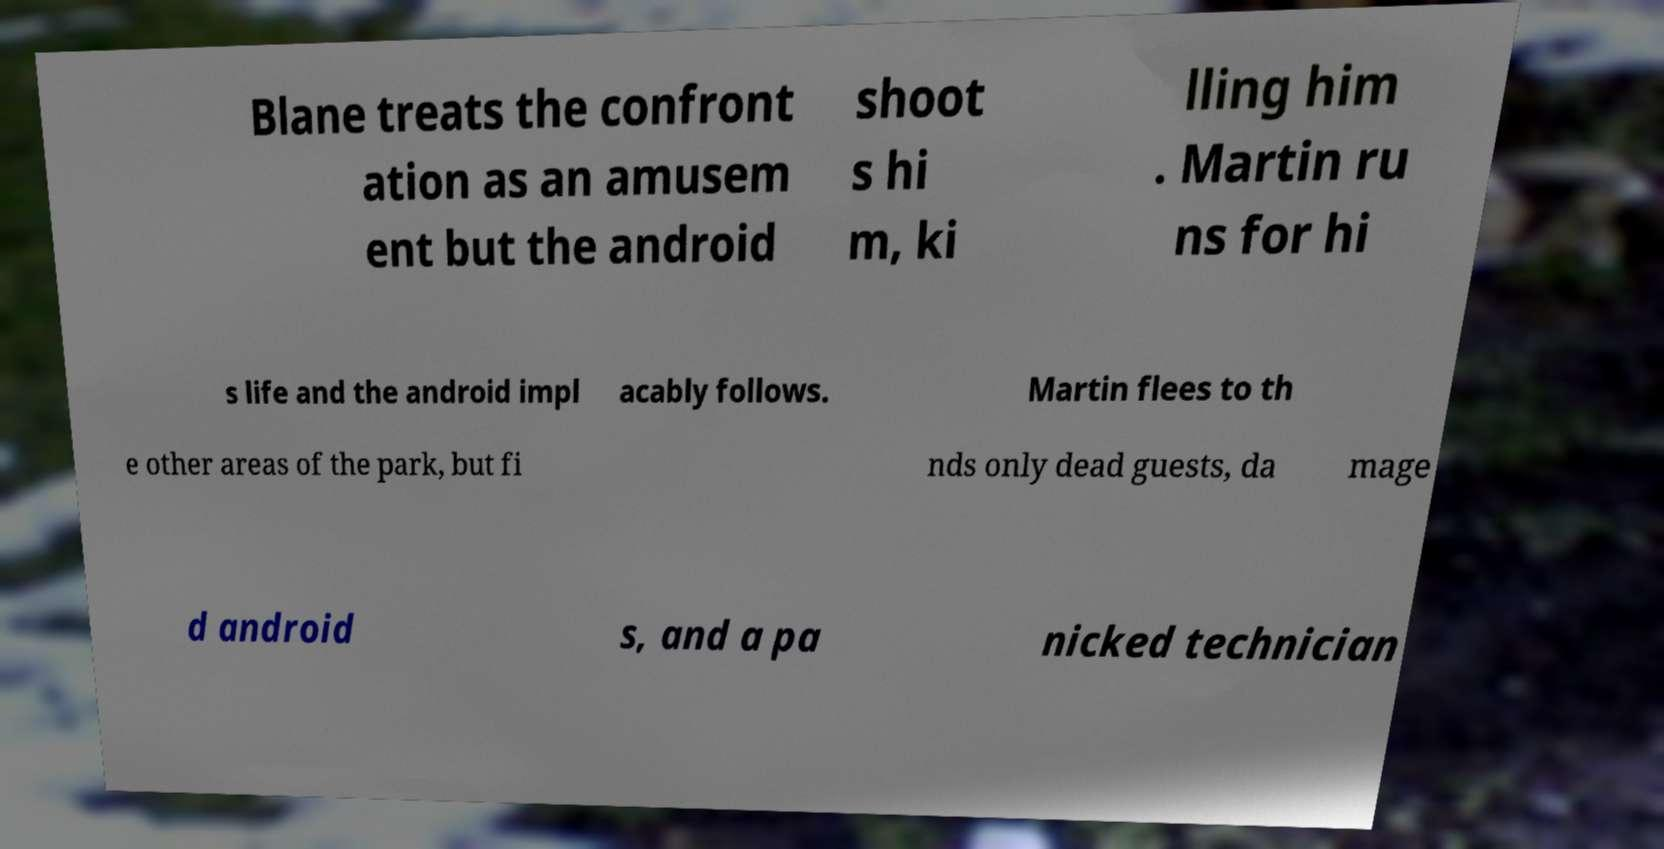For documentation purposes, I need the text within this image transcribed. Could you provide that? Blane treats the confront ation as an amusem ent but the android shoot s hi m, ki lling him . Martin ru ns for hi s life and the android impl acably follows. Martin flees to th e other areas of the park, but fi nds only dead guests, da mage d android s, and a pa nicked technician 